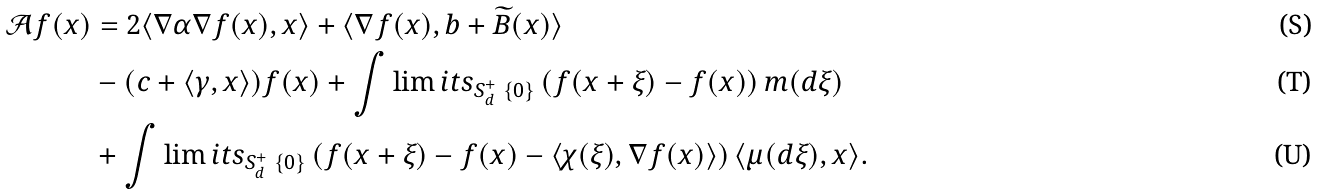<formula> <loc_0><loc_0><loc_500><loc_500>\mathcal { A } f ( x ) & = 2 \langle \nabla \alpha \nabla f ( x ) , x \rangle + \langle \nabla f ( x ) , b + \widetilde { B } ( x ) \rangle \\ \quad & - ( c + \langle \gamma , x \rangle ) f ( x ) + \int \lim i t s _ { S _ { d } ^ { + } \ \{ 0 \} } \left ( f ( x + \xi ) - f ( x ) \right ) m ( d \xi ) \\ \quad & + \int \lim i t s _ { S _ { d } ^ { + } \ \{ 0 \} } \left ( f ( x + \xi ) - f ( x ) - \langle \chi ( \xi ) , \nabla f ( x ) \rangle \right ) \langle \mu ( d \xi ) , x \rangle .</formula> 